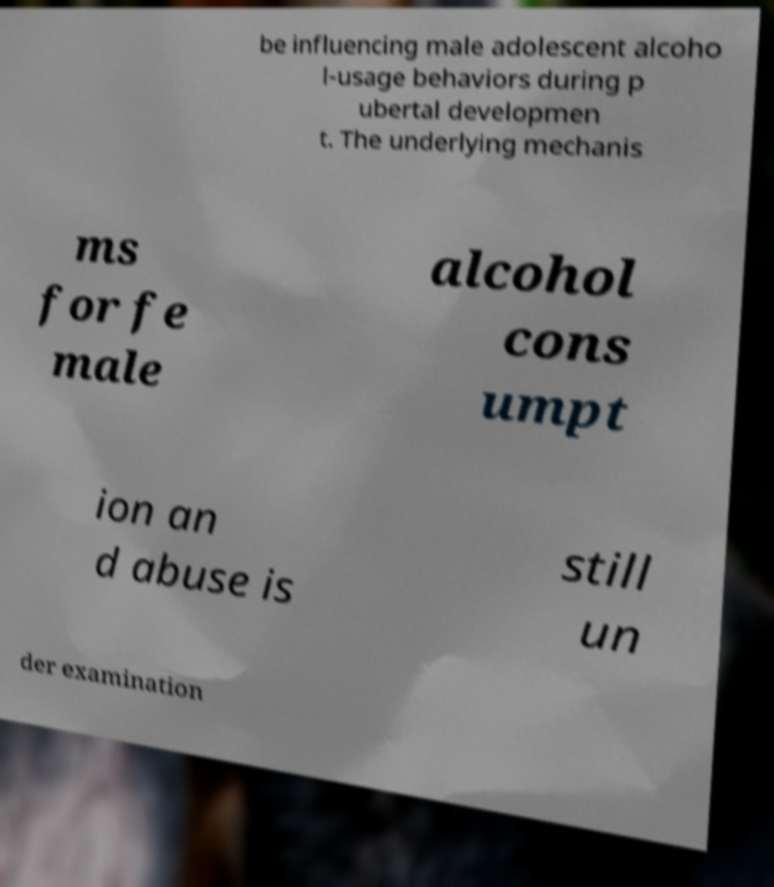Can you read and provide the text displayed in the image?This photo seems to have some interesting text. Can you extract and type it out for me? be influencing male adolescent alcoho l-usage behaviors during p ubertal developmen t. The underlying mechanis ms for fe male alcohol cons umpt ion an d abuse is still un der examination 